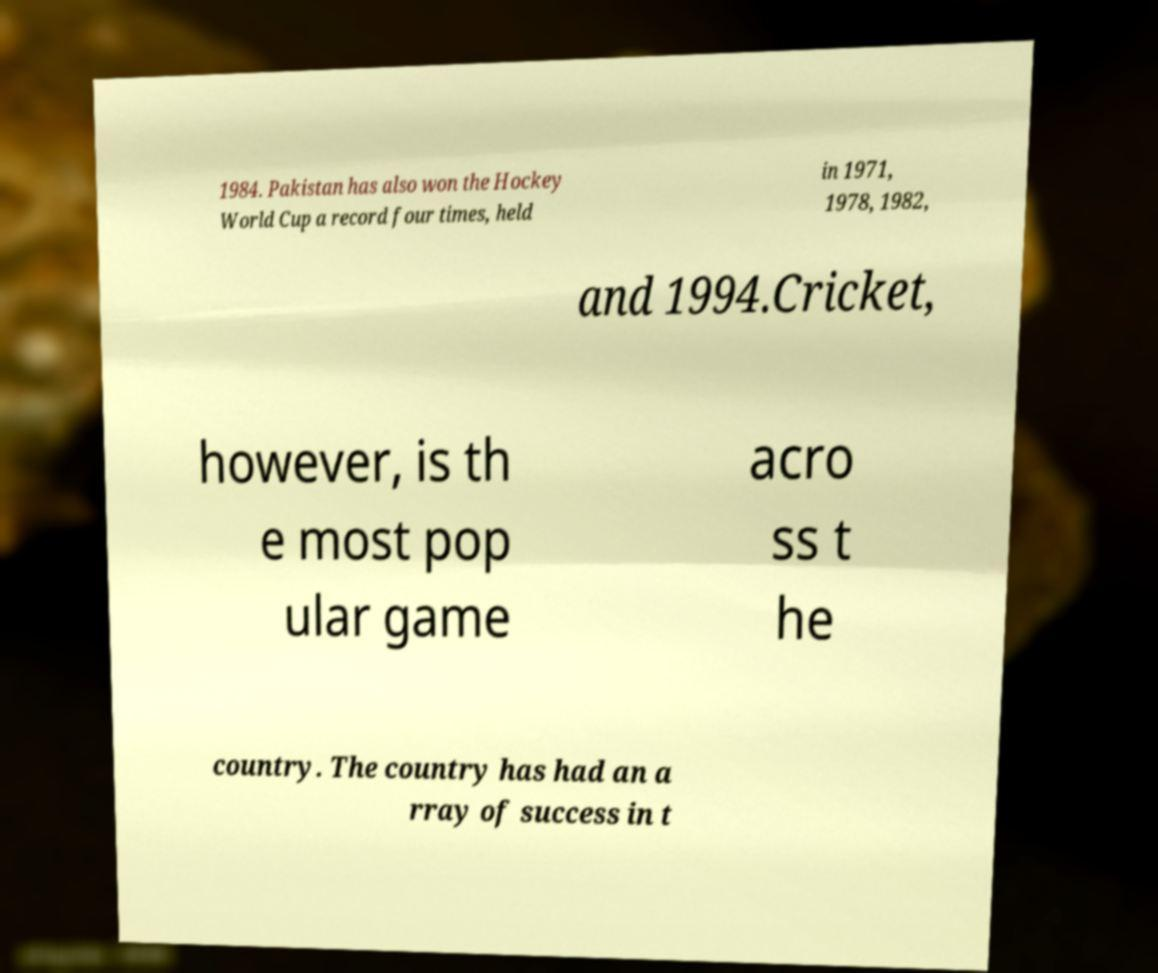There's text embedded in this image that I need extracted. Can you transcribe it verbatim? 1984. Pakistan has also won the Hockey World Cup a record four times, held in 1971, 1978, 1982, and 1994.Cricket, however, is th e most pop ular game acro ss t he country. The country has had an a rray of success in t 